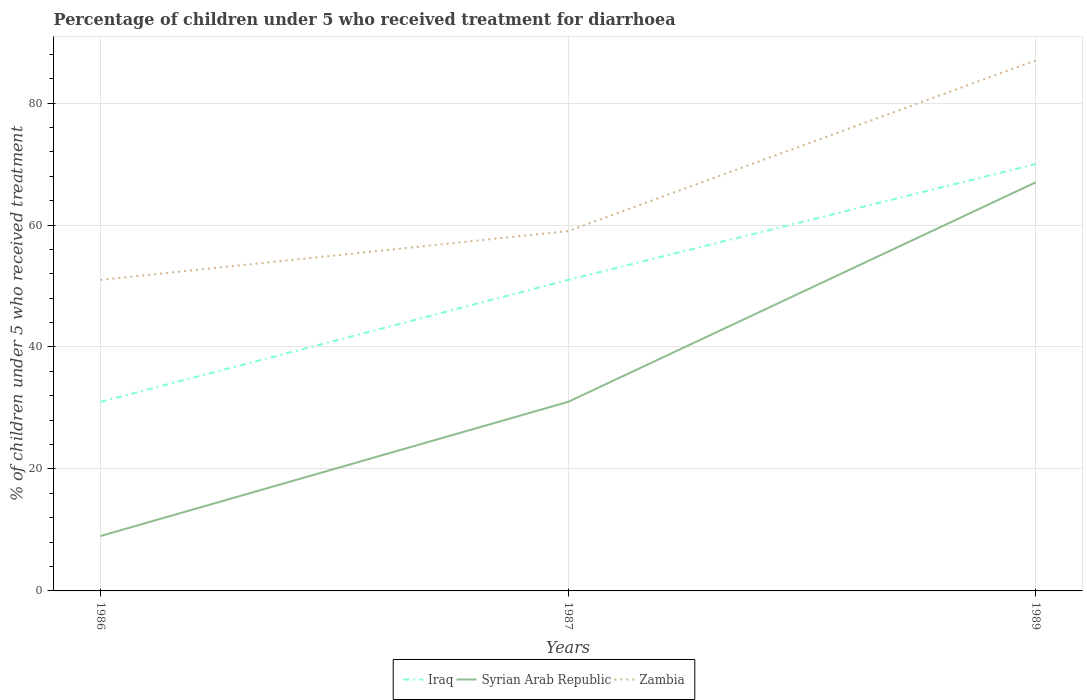Does the line corresponding to Iraq intersect with the line corresponding to Syrian Arab Republic?
Offer a very short reply. No. Is the number of lines equal to the number of legend labels?
Your answer should be very brief. Yes. Across all years, what is the maximum percentage of children who received treatment for diarrhoea  in Zambia?
Give a very brief answer. 51. What is the total percentage of children who received treatment for diarrhoea  in Iraq in the graph?
Provide a short and direct response. -39. What is the difference between two consecutive major ticks on the Y-axis?
Ensure brevity in your answer.  20. Are the values on the major ticks of Y-axis written in scientific E-notation?
Your response must be concise. No. Does the graph contain grids?
Offer a terse response. Yes. Where does the legend appear in the graph?
Make the answer very short. Bottom center. How many legend labels are there?
Your answer should be very brief. 3. How are the legend labels stacked?
Your answer should be very brief. Horizontal. What is the title of the graph?
Ensure brevity in your answer.  Percentage of children under 5 who received treatment for diarrhoea. Does "Montenegro" appear as one of the legend labels in the graph?
Keep it short and to the point. No. What is the label or title of the X-axis?
Make the answer very short. Years. What is the label or title of the Y-axis?
Your response must be concise. % of children under 5 who received treatment. What is the % of children under 5 who received treatment of Iraq in 1986?
Provide a short and direct response. 31. What is the % of children under 5 who received treatment in Zambia in 1986?
Offer a very short reply. 51. What is the % of children under 5 who received treatment in Zambia in 1987?
Provide a short and direct response. 59. What is the % of children under 5 who received treatment of Iraq in 1989?
Provide a short and direct response. 70. What is the % of children under 5 who received treatment in Syrian Arab Republic in 1989?
Your answer should be very brief. 67. Across all years, what is the maximum % of children under 5 who received treatment of Zambia?
Give a very brief answer. 87. Across all years, what is the minimum % of children under 5 who received treatment of Iraq?
Give a very brief answer. 31. Across all years, what is the minimum % of children under 5 who received treatment of Syrian Arab Republic?
Offer a terse response. 9. What is the total % of children under 5 who received treatment of Iraq in the graph?
Offer a terse response. 152. What is the total % of children under 5 who received treatment of Syrian Arab Republic in the graph?
Keep it short and to the point. 107. What is the total % of children under 5 who received treatment of Zambia in the graph?
Your answer should be compact. 197. What is the difference between the % of children under 5 who received treatment of Iraq in 1986 and that in 1987?
Your response must be concise. -20. What is the difference between the % of children under 5 who received treatment in Syrian Arab Republic in 1986 and that in 1987?
Provide a succinct answer. -22. What is the difference between the % of children under 5 who received treatment in Zambia in 1986 and that in 1987?
Keep it short and to the point. -8. What is the difference between the % of children under 5 who received treatment of Iraq in 1986 and that in 1989?
Provide a short and direct response. -39. What is the difference between the % of children under 5 who received treatment in Syrian Arab Republic in 1986 and that in 1989?
Offer a very short reply. -58. What is the difference between the % of children under 5 who received treatment of Zambia in 1986 and that in 1989?
Ensure brevity in your answer.  -36. What is the difference between the % of children under 5 who received treatment in Syrian Arab Republic in 1987 and that in 1989?
Make the answer very short. -36. What is the difference between the % of children under 5 who received treatment of Iraq in 1986 and the % of children under 5 who received treatment of Syrian Arab Republic in 1987?
Ensure brevity in your answer.  0. What is the difference between the % of children under 5 who received treatment in Syrian Arab Republic in 1986 and the % of children under 5 who received treatment in Zambia in 1987?
Make the answer very short. -50. What is the difference between the % of children under 5 who received treatment of Iraq in 1986 and the % of children under 5 who received treatment of Syrian Arab Republic in 1989?
Provide a succinct answer. -36. What is the difference between the % of children under 5 who received treatment of Iraq in 1986 and the % of children under 5 who received treatment of Zambia in 1989?
Your answer should be compact. -56. What is the difference between the % of children under 5 who received treatment of Syrian Arab Republic in 1986 and the % of children under 5 who received treatment of Zambia in 1989?
Offer a very short reply. -78. What is the difference between the % of children under 5 who received treatment in Iraq in 1987 and the % of children under 5 who received treatment in Syrian Arab Republic in 1989?
Provide a short and direct response. -16. What is the difference between the % of children under 5 who received treatment of Iraq in 1987 and the % of children under 5 who received treatment of Zambia in 1989?
Give a very brief answer. -36. What is the difference between the % of children under 5 who received treatment of Syrian Arab Republic in 1987 and the % of children under 5 who received treatment of Zambia in 1989?
Your response must be concise. -56. What is the average % of children under 5 who received treatment of Iraq per year?
Offer a terse response. 50.67. What is the average % of children under 5 who received treatment in Syrian Arab Republic per year?
Offer a very short reply. 35.67. What is the average % of children under 5 who received treatment in Zambia per year?
Make the answer very short. 65.67. In the year 1986, what is the difference between the % of children under 5 who received treatment of Syrian Arab Republic and % of children under 5 who received treatment of Zambia?
Give a very brief answer. -42. In the year 1987, what is the difference between the % of children under 5 who received treatment in Iraq and % of children under 5 who received treatment in Syrian Arab Republic?
Offer a terse response. 20. What is the ratio of the % of children under 5 who received treatment in Iraq in 1986 to that in 1987?
Provide a succinct answer. 0.61. What is the ratio of the % of children under 5 who received treatment in Syrian Arab Republic in 1986 to that in 1987?
Your response must be concise. 0.29. What is the ratio of the % of children under 5 who received treatment in Zambia in 1986 to that in 1987?
Provide a short and direct response. 0.86. What is the ratio of the % of children under 5 who received treatment of Iraq in 1986 to that in 1989?
Your answer should be very brief. 0.44. What is the ratio of the % of children under 5 who received treatment of Syrian Arab Republic in 1986 to that in 1989?
Your answer should be very brief. 0.13. What is the ratio of the % of children under 5 who received treatment in Zambia in 1986 to that in 1989?
Your answer should be very brief. 0.59. What is the ratio of the % of children under 5 who received treatment in Iraq in 1987 to that in 1989?
Your answer should be very brief. 0.73. What is the ratio of the % of children under 5 who received treatment in Syrian Arab Republic in 1987 to that in 1989?
Ensure brevity in your answer.  0.46. What is the ratio of the % of children under 5 who received treatment in Zambia in 1987 to that in 1989?
Make the answer very short. 0.68. What is the difference between the highest and the second highest % of children under 5 who received treatment of Syrian Arab Republic?
Offer a terse response. 36. What is the difference between the highest and the second highest % of children under 5 who received treatment in Zambia?
Keep it short and to the point. 28. What is the difference between the highest and the lowest % of children under 5 who received treatment in Zambia?
Your response must be concise. 36. 